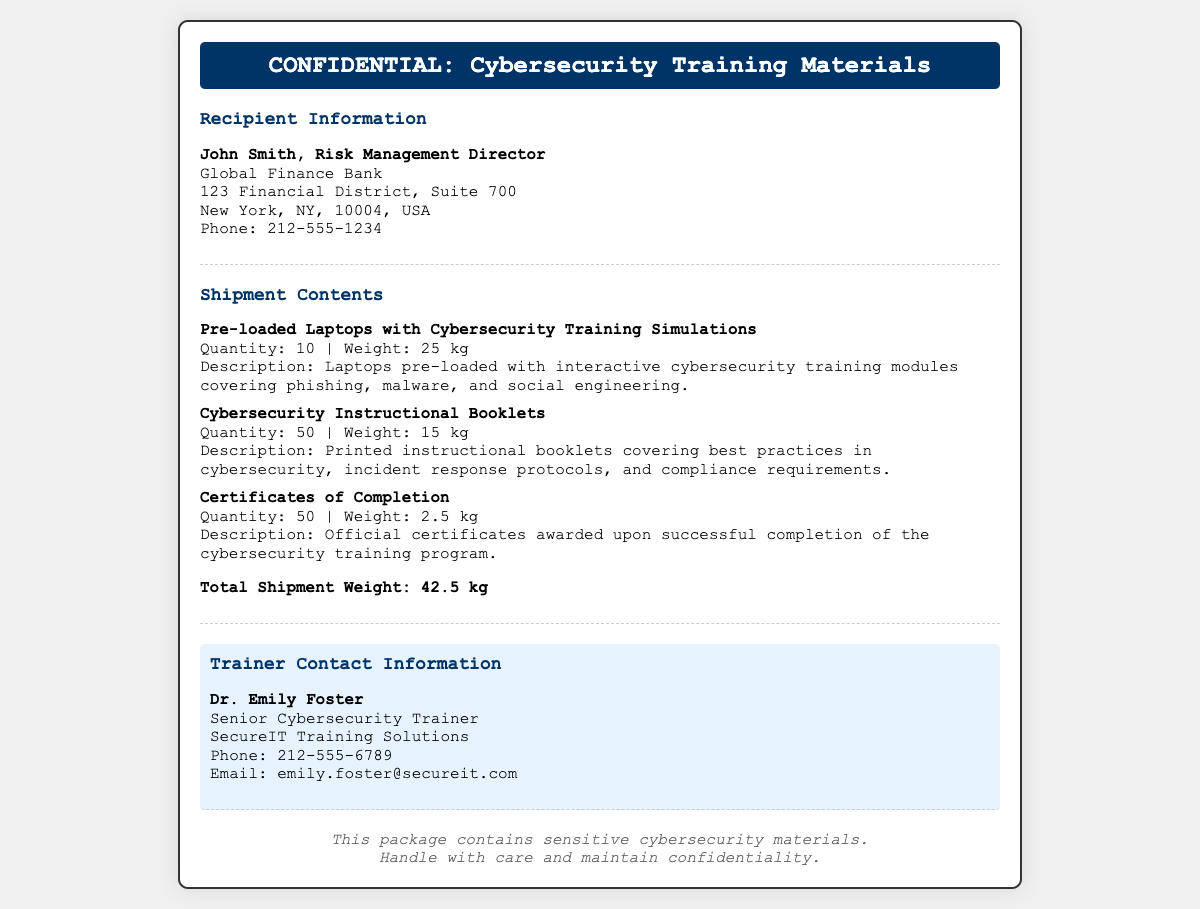What is the total shipment weight? The total shipment weight is clearly stated in the document at the end of the "Shipment Contents" section.
Answer: 42.5 kg Who is the recipient? The recipient's name and title are given in the "Recipient Information" section at the beginning of the document.
Answer: John Smith How many laptops are included in the shipment? The quantity of laptops is mentioned in the details of the "Shipment Contents" section.
Answer: 10 What is the phone number of the trainer? The trainer's contact information includes the phone number located in the "Trainer Contact Information" section.
Answer: 212-555-6789 What type of materials are these? The header of the document specifies the type of materials being shipped.
Answer: Cybersecurity Training Materials How many instructional booklets are there? The quantity of instructional booklets is provided in the "Shipment Contents" section.
Answer: 50 What organization is the trainer affiliated with? The trainer's contact information states the organization they are associated with.
Answer: SecureIT Training Solutions What is the main focus of the training simulations? The description for the laptops specifies the key focus areas of the training modules.
Answer: Phishing, malware, and social engineering 